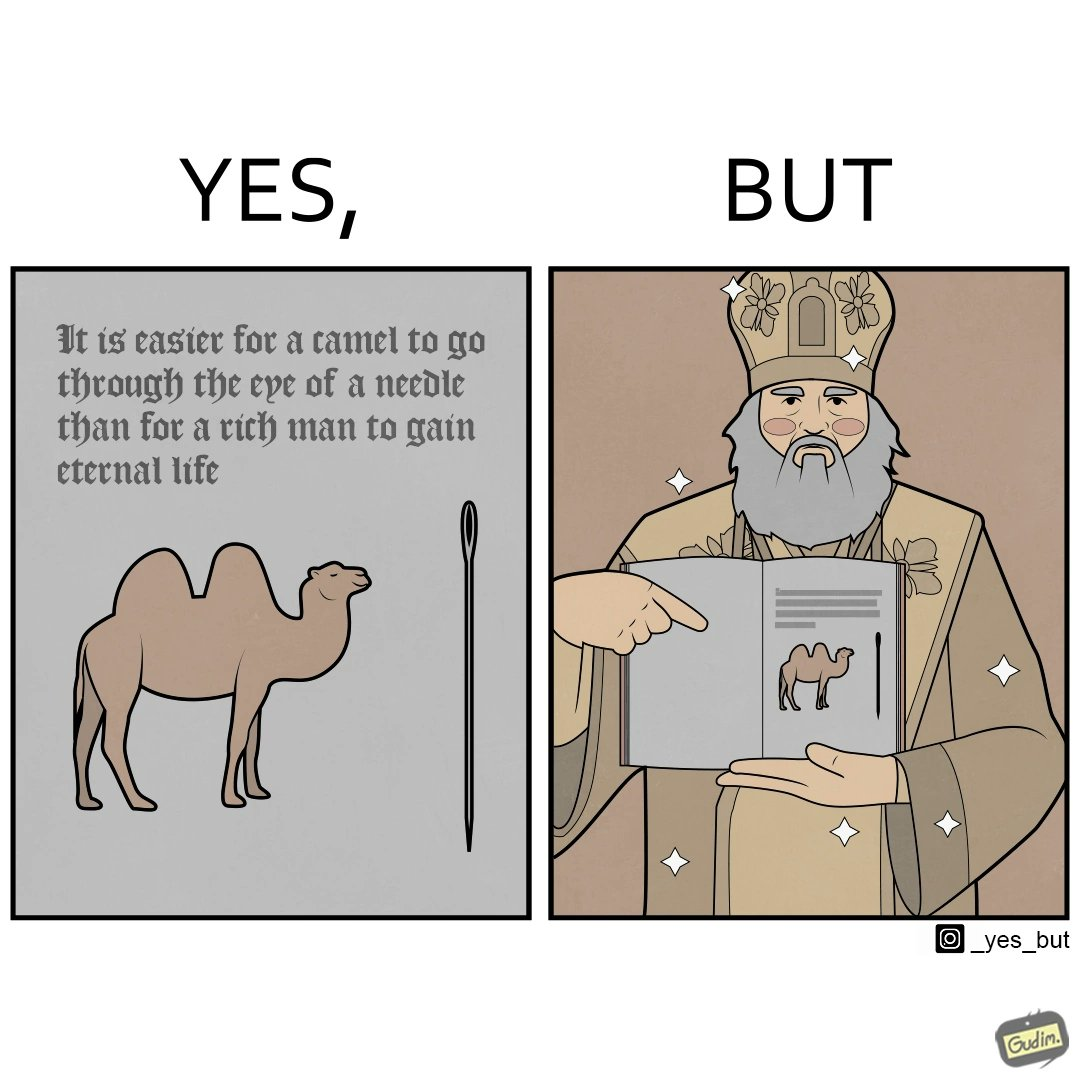Would you classify this image as satirical? Yes, this image is satirical. 